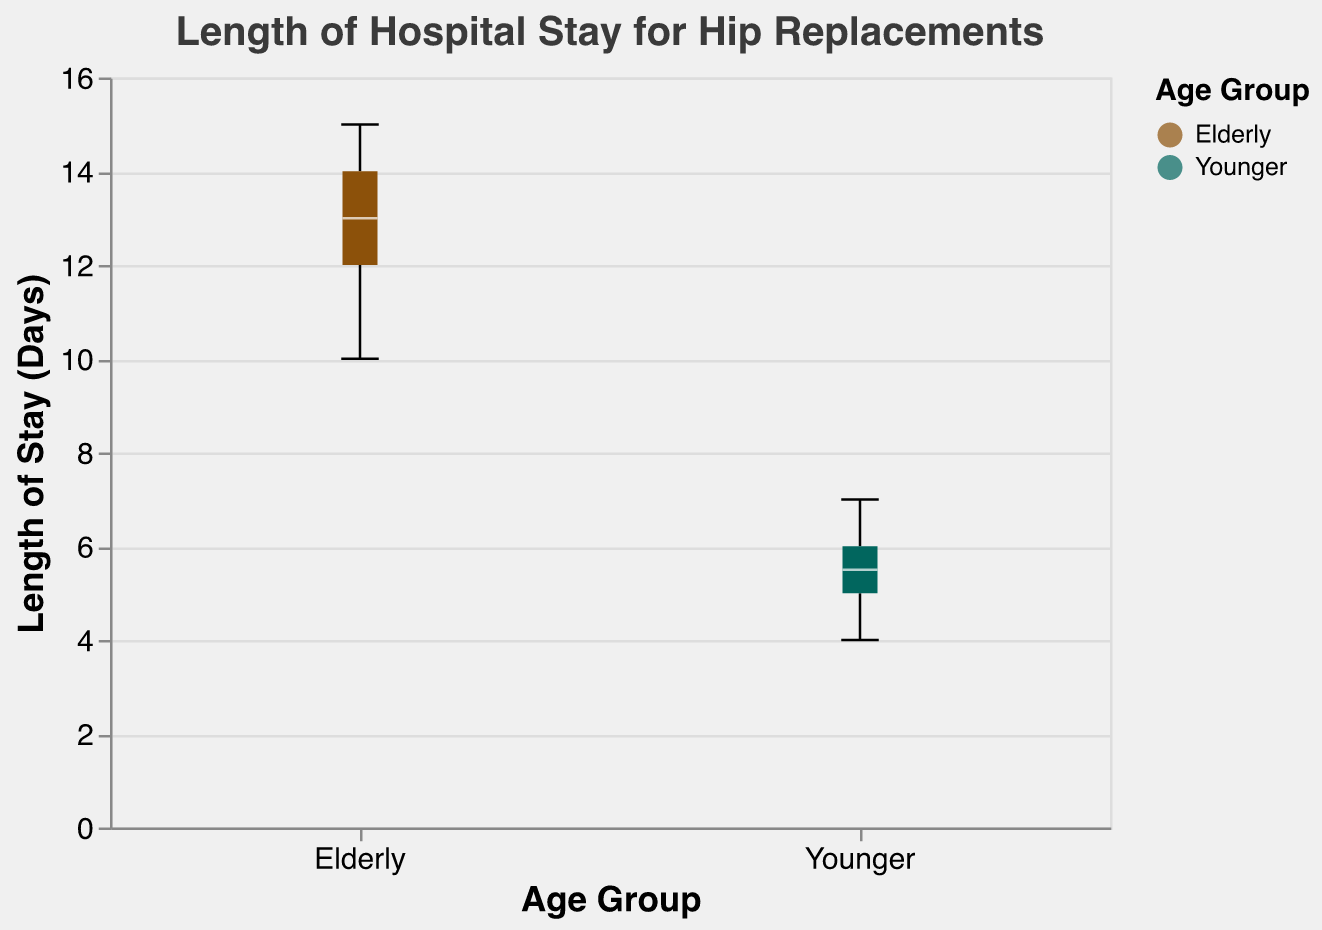What's the title of the chart? The title is usually displayed at the top of the chart and describes the content. It helps understand the context of the data displayed.
Answer: Length of Hospital Stay for Hip Replacements How many elderly patients were included in the data? The number of data points for elderly patients can be determined by counting the number of points or boxplots corresponding to the "Elderly" group.
Answer: 10 Which age group has the higher median length of stay? The median is depicted by a line inside the box plot. By comparing the median lines of both groups, we can determine which one is higher.
Answer: Elderly What's the interquartile range (IQR) for the younger age group? The IQR is the range between the 25th percentile (bottom of the box) and the 75th percentile (top of the box). Observing the visual boundaries of the box for the younger group will yield the IQR.
Answer: 2 What's the maximum length of stay for elderly patients? The maximum value can be found by looking at the top whisker or the highest point in the box plot representing the elderly group.
Answer: 15 Which age group has more variability in the length of stay? Variability can be assessed by looking at the range of data points (length of whiskers) or the IQR (length of the box).
Answer: Elderly What is the difference between the median lengths of stay for elderly and younger patients? To find the difference, subtract the median value for the younger group from the median value for the elderly group. This requires identifying both medians from the box plots and performing the subtraction.
Answer: 7 days What’s the range of the length of stay for younger patients? Range is calculated as the difference between the maximum and minimum values, which are the top and bottom whiskers of the box plot for the younger group.
Answer: 3 days What colors represent the elderly and younger groups in the chart? The colors used in the box plots for different groups can be identified by looking at the corresponding legends.
Answer: Brown for Elderly, Green for Younger What's the interquartile range (IQR) for the elderly age group? The IQR is the difference between the 75th percentile and the 25th percentile. Observing the visual boundaries of the box for the elderly group will yield the IQR.
Answer: 3 